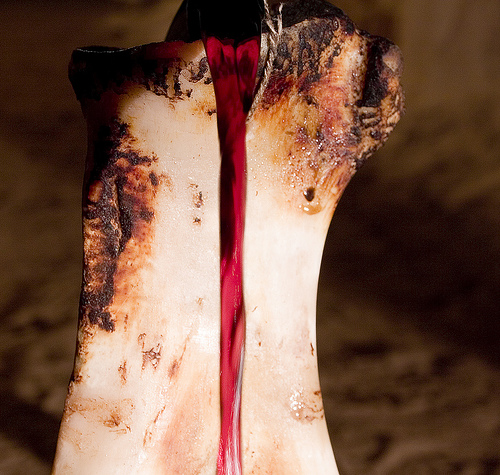<image>
Is the blood in the bone? No. The blood is not contained within the bone. These objects have a different spatial relationship. 